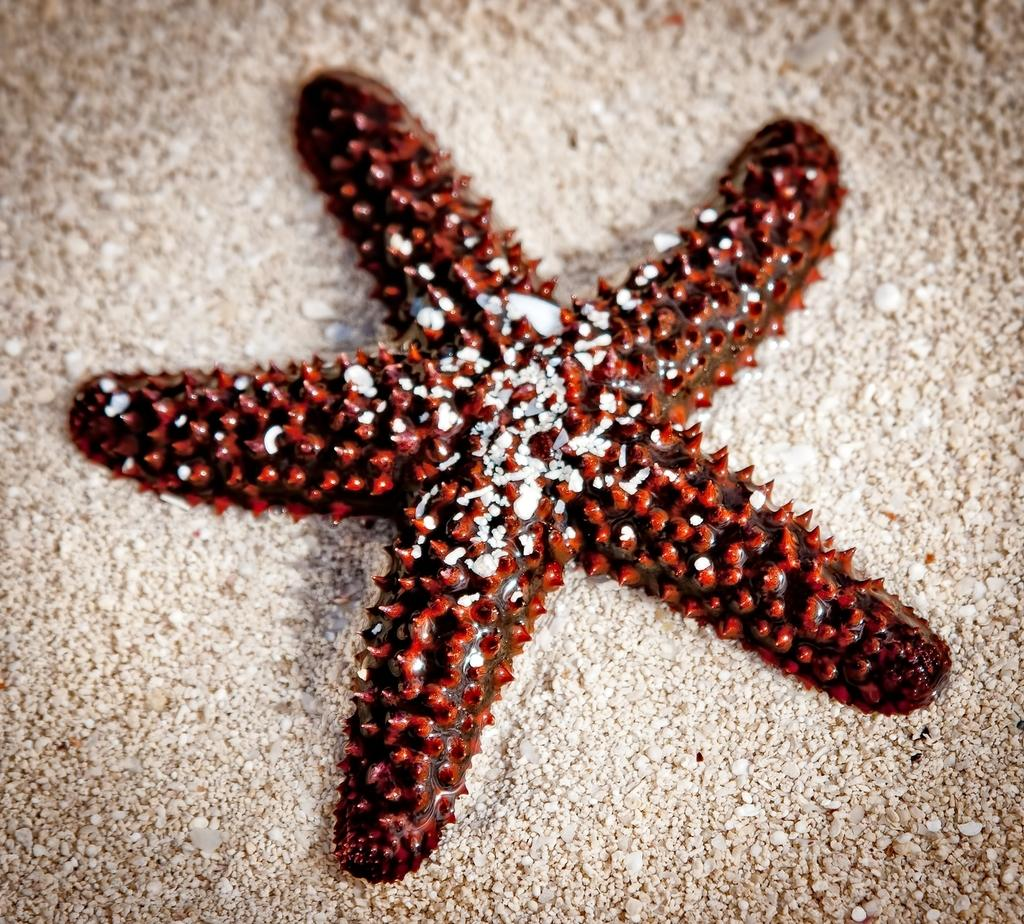What is the main subject of the image? There is a starfish in the image. Where is the starfish located in the image? The starfish is in the center of the image. What color is the starfish? The starfish is red in color. How many spiders are exchanging poison in the image? There are no spiders or poison exchange present in the image; it features a red starfish in the center. 